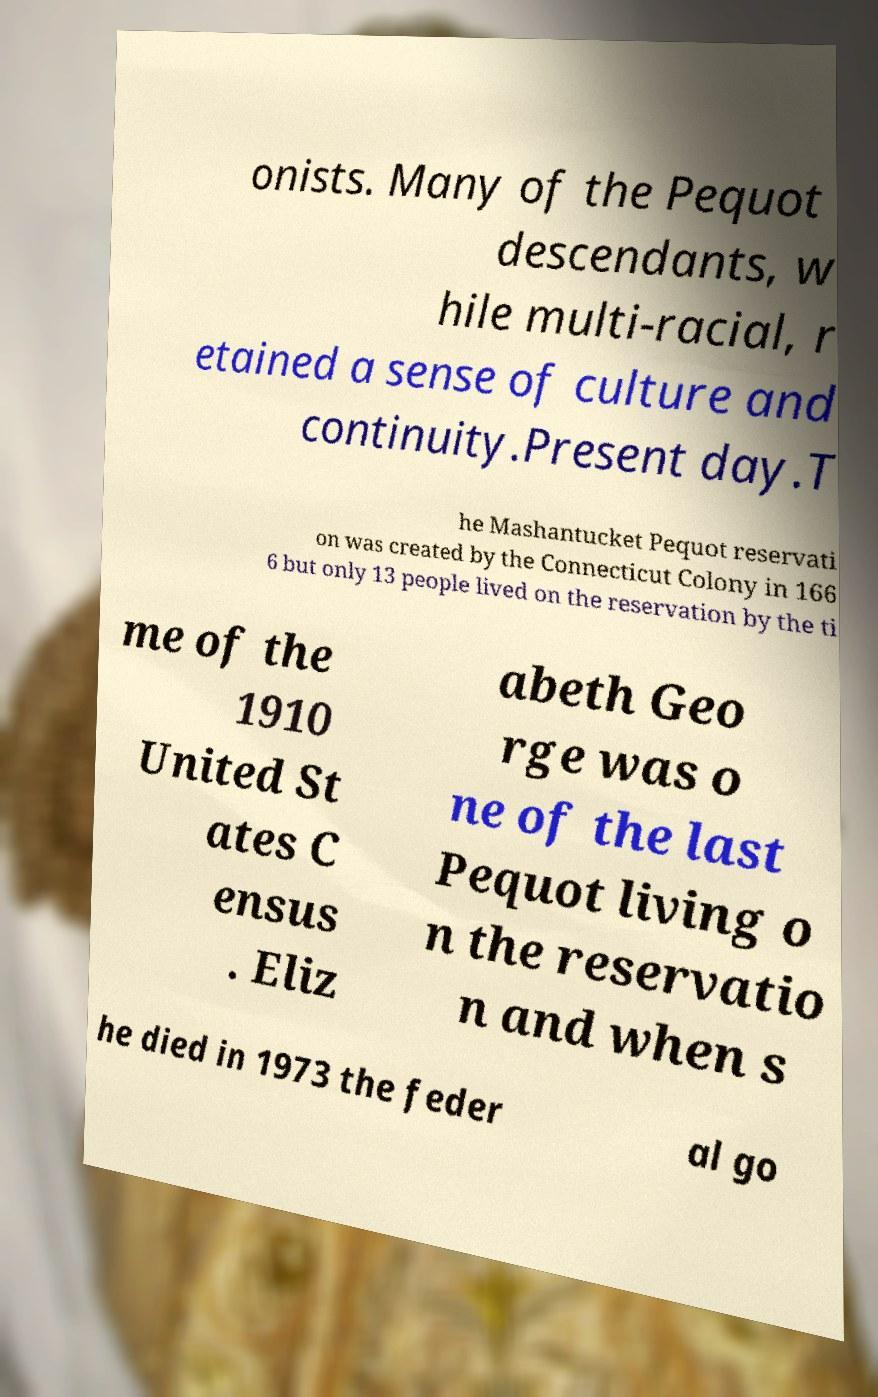Can you accurately transcribe the text from the provided image for me? onists. Many of the Pequot descendants, w hile multi-racial, r etained a sense of culture and continuity.Present day.T he Mashantucket Pequot reservati on was created by the Connecticut Colony in 166 6 but only 13 people lived on the reservation by the ti me of the 1910 United St ates C ensus . Eliz abeth Geo rge was o ne of the last Pequot living o n the reservatio n and when s he died in 1973 the feder al go 